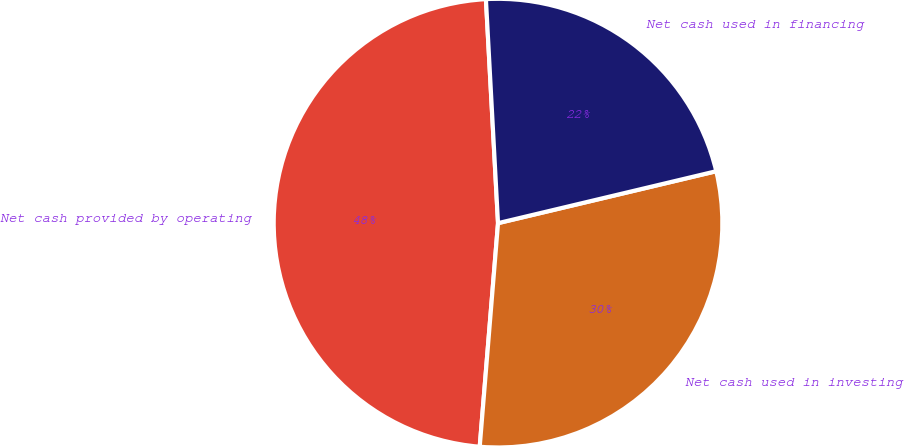<chart> <loc_0><loc_0><loc_500><loc_500><pie_chart><fcel>Net cash provided by operating<fcel>Net cash used in investing<fcel>Net cash used in financing<nl><fcel>47.84%<fcel>30.02%<fcel>22.14%<nl></chart> 